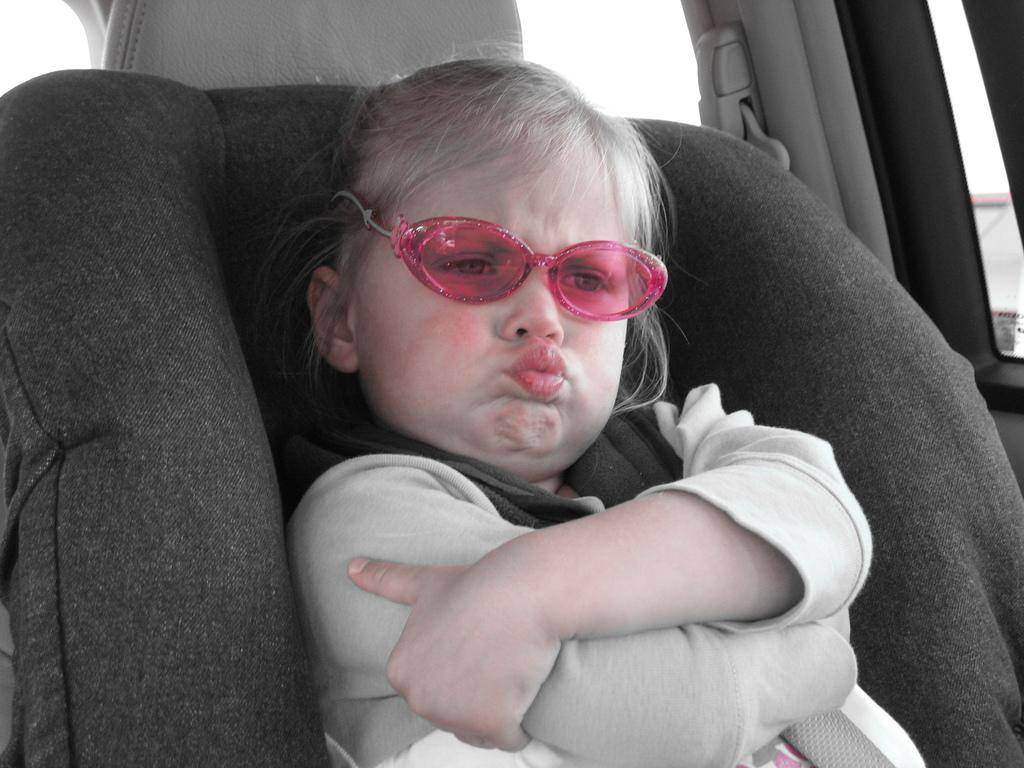What is the main subject of the image? There is a baby in the image. What is the baby wearing? The baby is wearing a white dress. Where is the baby sitting? The baby is sitting on a seat. What type of location is the baby in? The baby is inside a vehicle. What is the rate of the baby's heartbeat in the image? The image does not provide information about the baby's heartbeat, so it cannot be determined. 